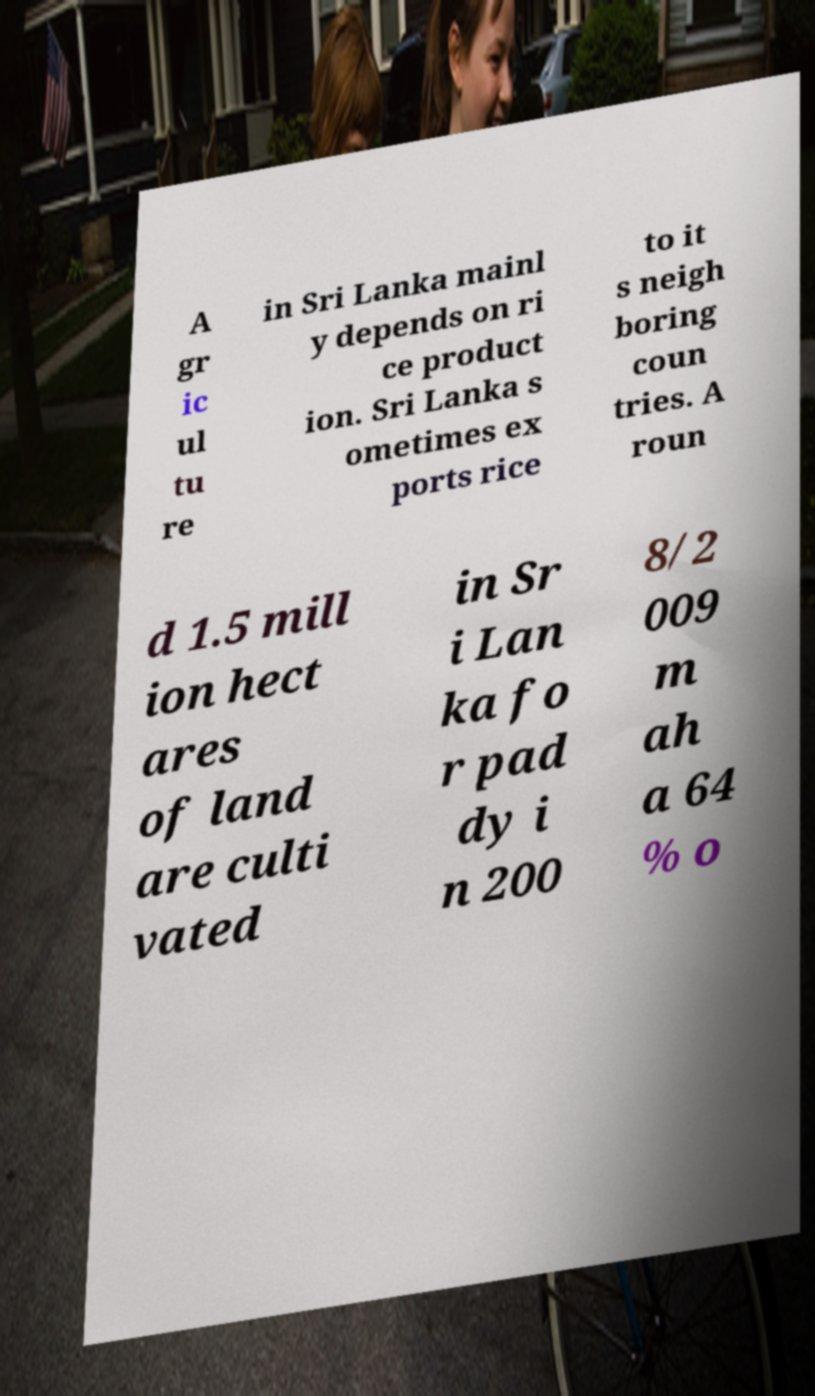What messages or text are displayed in this image? I need them in a readable, typed format. A gr ic ul tu re in Sri Lanka mainl y depends on ri ce product ion. Sri Lanka s ometimes ex ports rice to it s neigh boring coun tries. A roun d 1.5 mill ion hect ares of land are culti vated in Sr i Lan ka fo r pad dy i n 200 8/2 009 m ah a 64 % o 